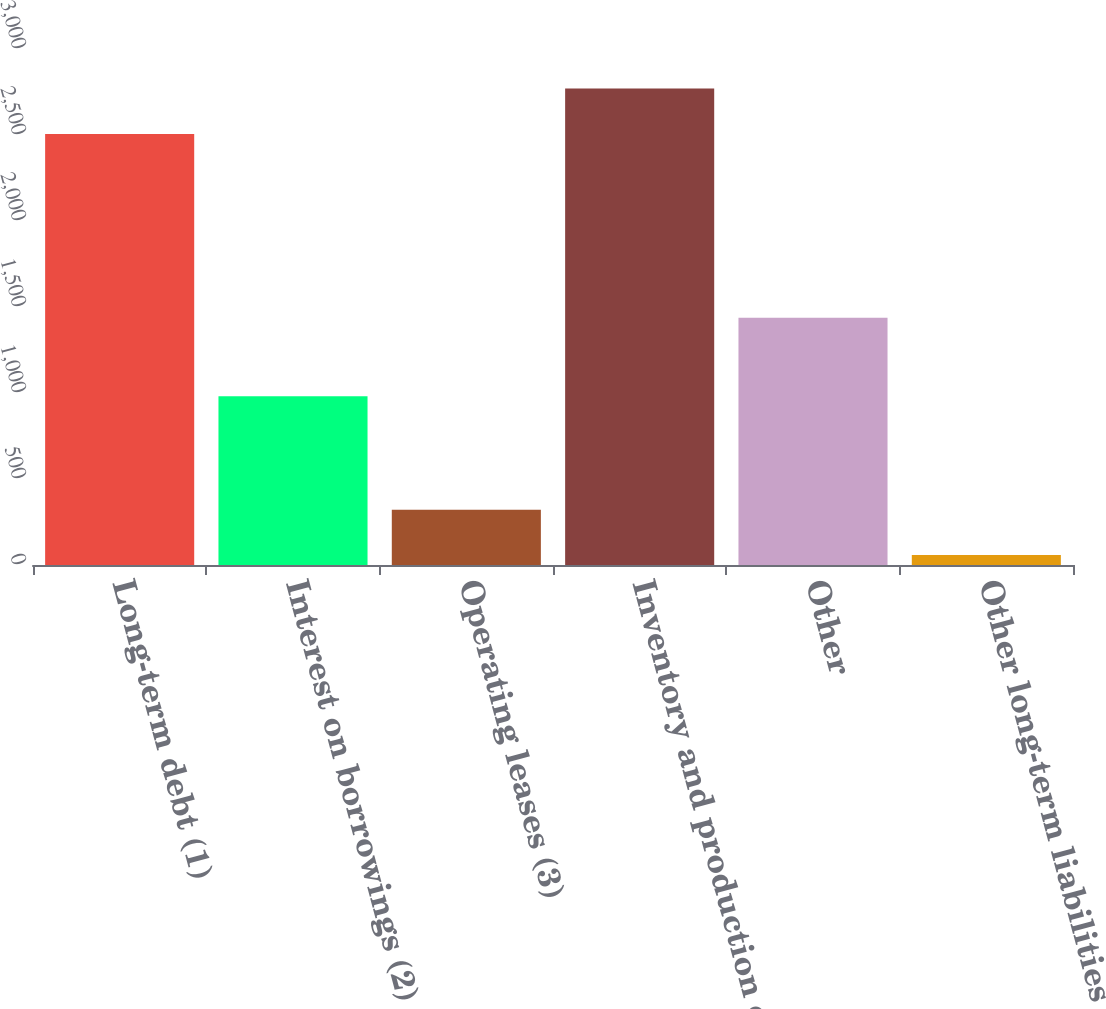Convert chart. <chart><loc_0><loc_0><loc_500><loc_500><bar_chart><fcel>Long-term debt (1)<fcel>Interest on borrowings (2)<fcel>Operating leases (3)<fcel>Inventory and production costs<fcel>Other<fcel>Other long-term liabilities<nl><fcel>2506<fcel>981<fcel>321.8<fcel>2769.8<fcel>1437<fcel>58<nl></chart> 